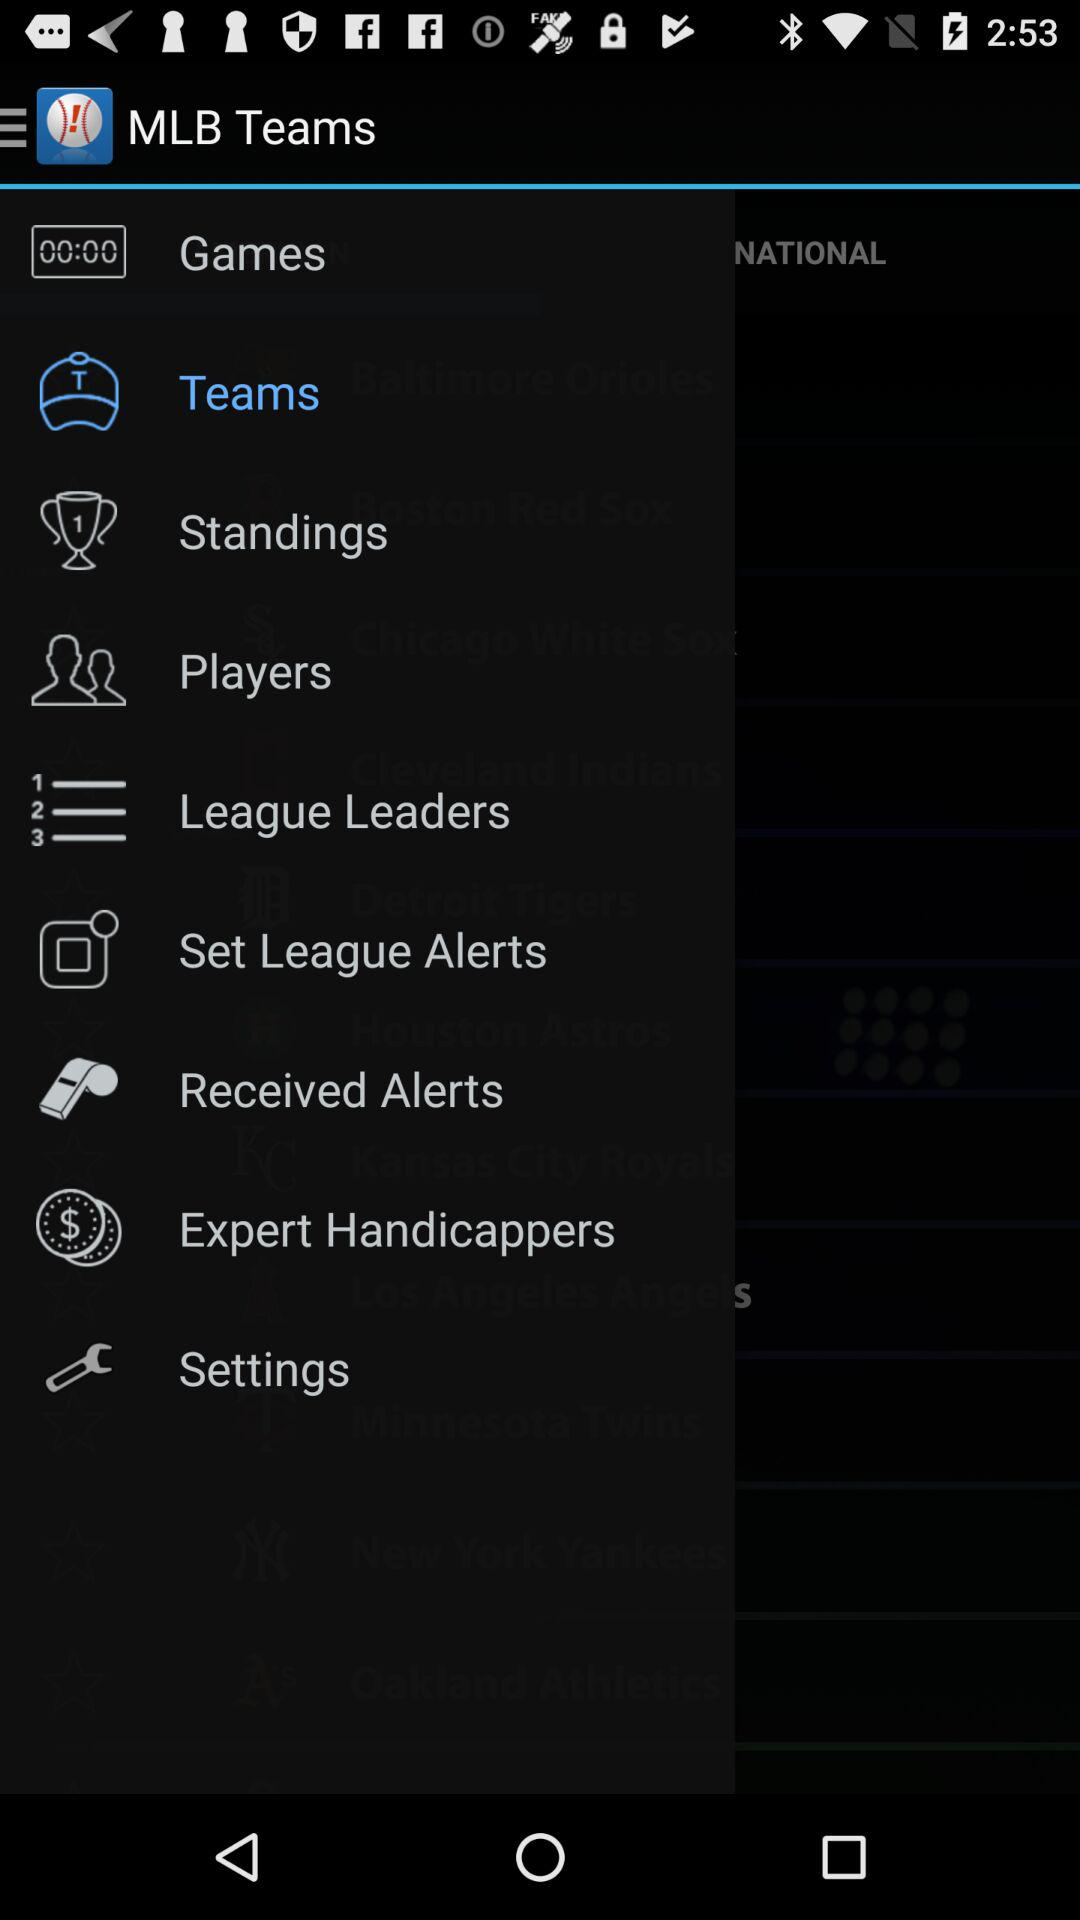What is the name of the application? The name of the application is "MLB Teams". 